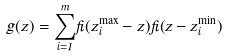Convert formula to latex. <formula><loc_0><loc_0><loc_500><loc_500>g ( z ) = { \sum _ { i = 1 } ^ { m } } { \Theta } ( z _ { i } ^ { \max } - z ) { \Theta } ( z - z _ { i } ^ { \min } )</formula> 